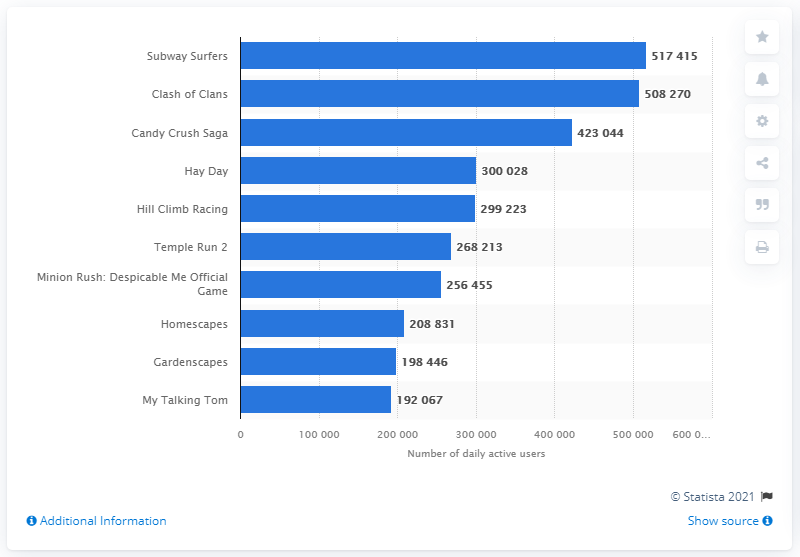Indicate a few pertinent items in this graphic. I, [Your Name], hereby declare that the game that came in second place with over 508 thousand daily active users is Clash of Clans. As of April 2021, the daily active users (DAU) of the game "Subway Surfers" were 517,415. 